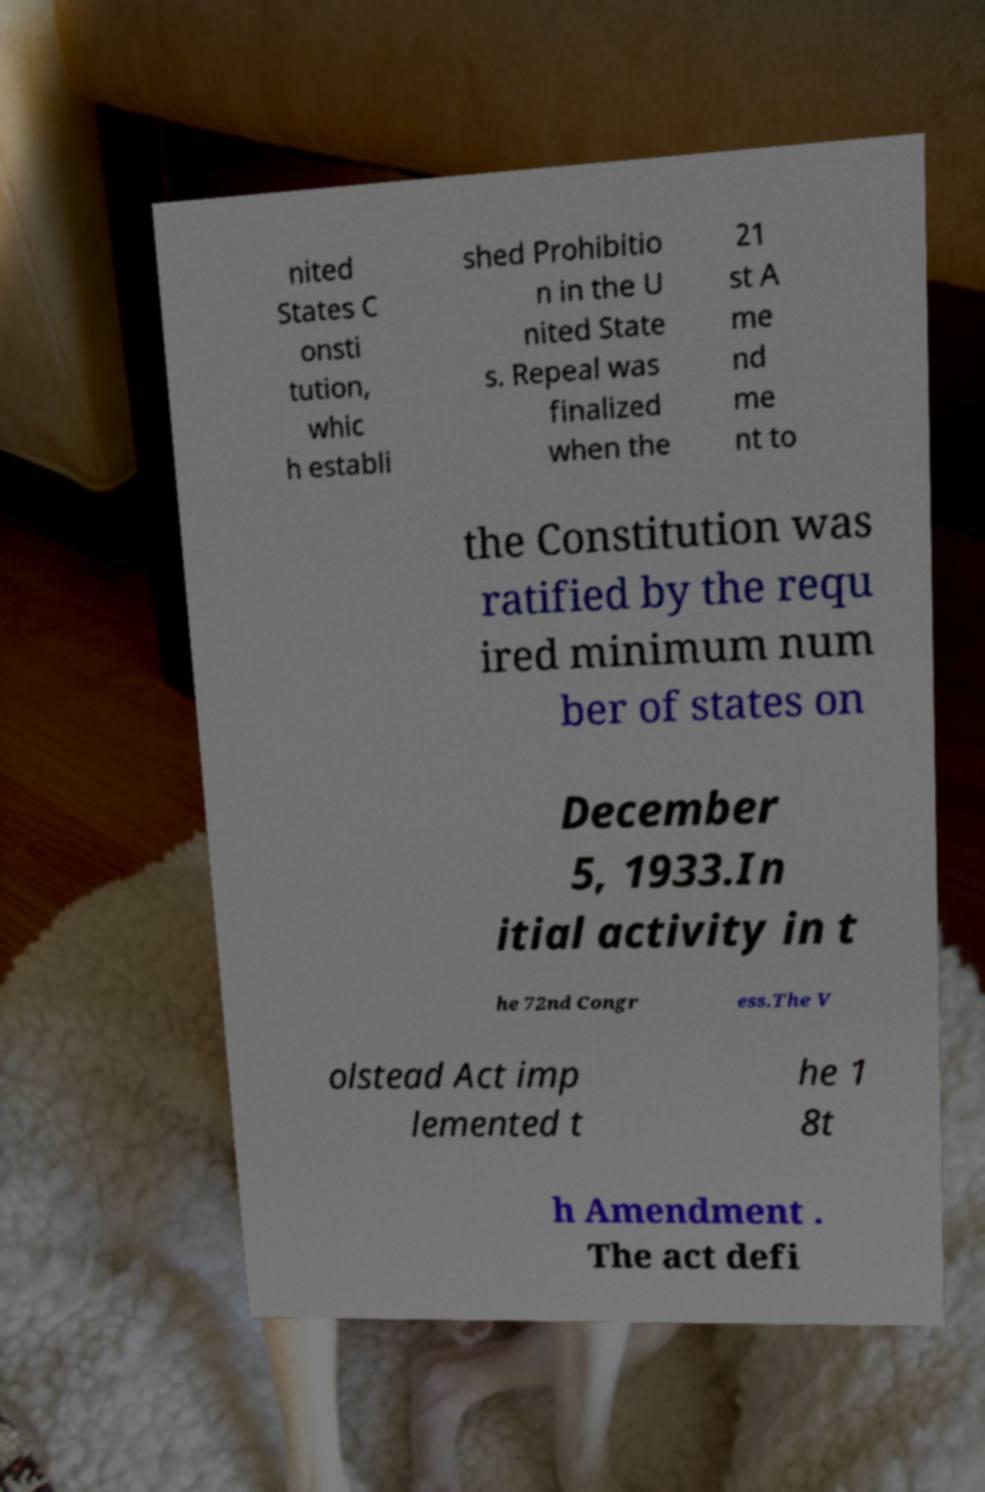Can you read and provide the text displayed in the image?This photo seems to have some interesting text. Can you extract and type it out for me? nited States C onsti tution, whic h establi shed Prohibitio n in the U nited State s. Repeal was finalized when the 21 st A me nd me nt to the Constitution was ratified by the requ ired minimum num ber of states on December 5, 1933.In itial activity in t he 72nd Congr ess.The V olstead Act imp lemented t he 1 8t h Amendment . The act defi 